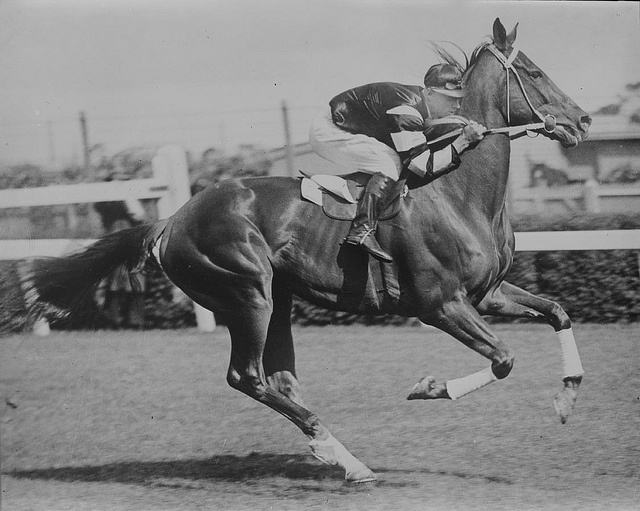Describe the objects in this image and their specific colors. I can see horse in darkgray, gray, black, and lightgray tones and people in darkgray, gray, black, and lightgray tones in this image. 